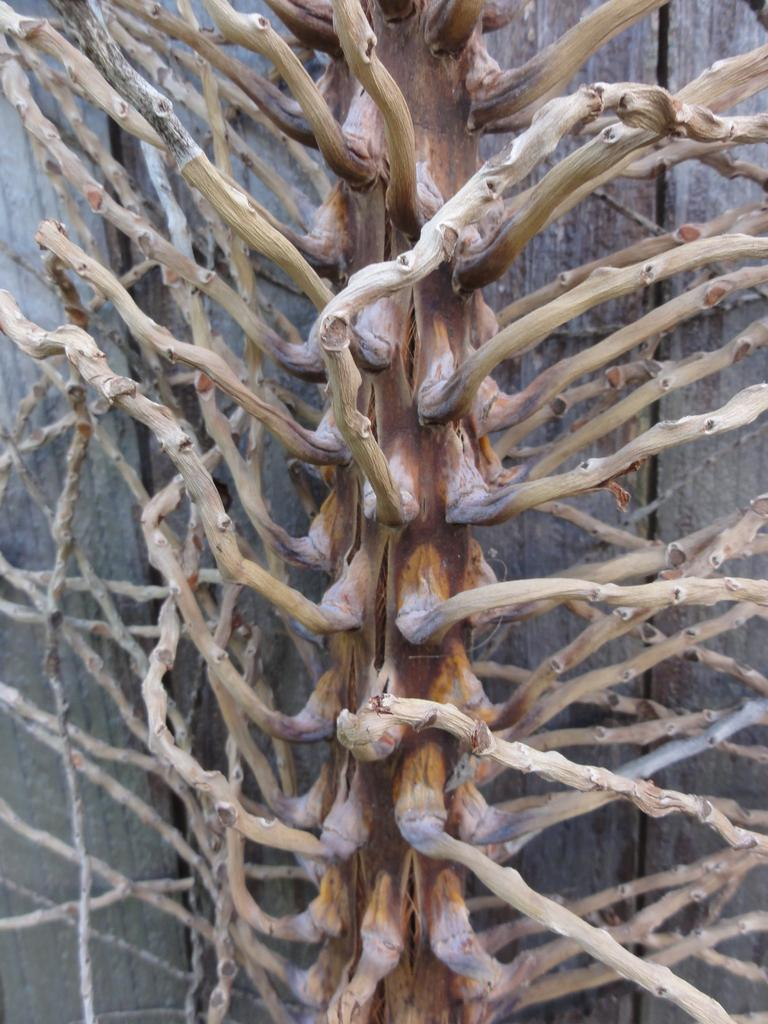What is the main subject of the image? The main subject of the image is a dried part of a plant. What is the dried plant placed on? The dried plant is on a wooden surface. What colors can be seen in the dried plant? The dried plant is ash and brown in color. What type of company is depicted in the image? There is no company depicted in the image; it features a dried part of a plant on a wooden surface. How many rings are visible on the dried plant in the image? There are no rings visible on the dried plant in the image. 